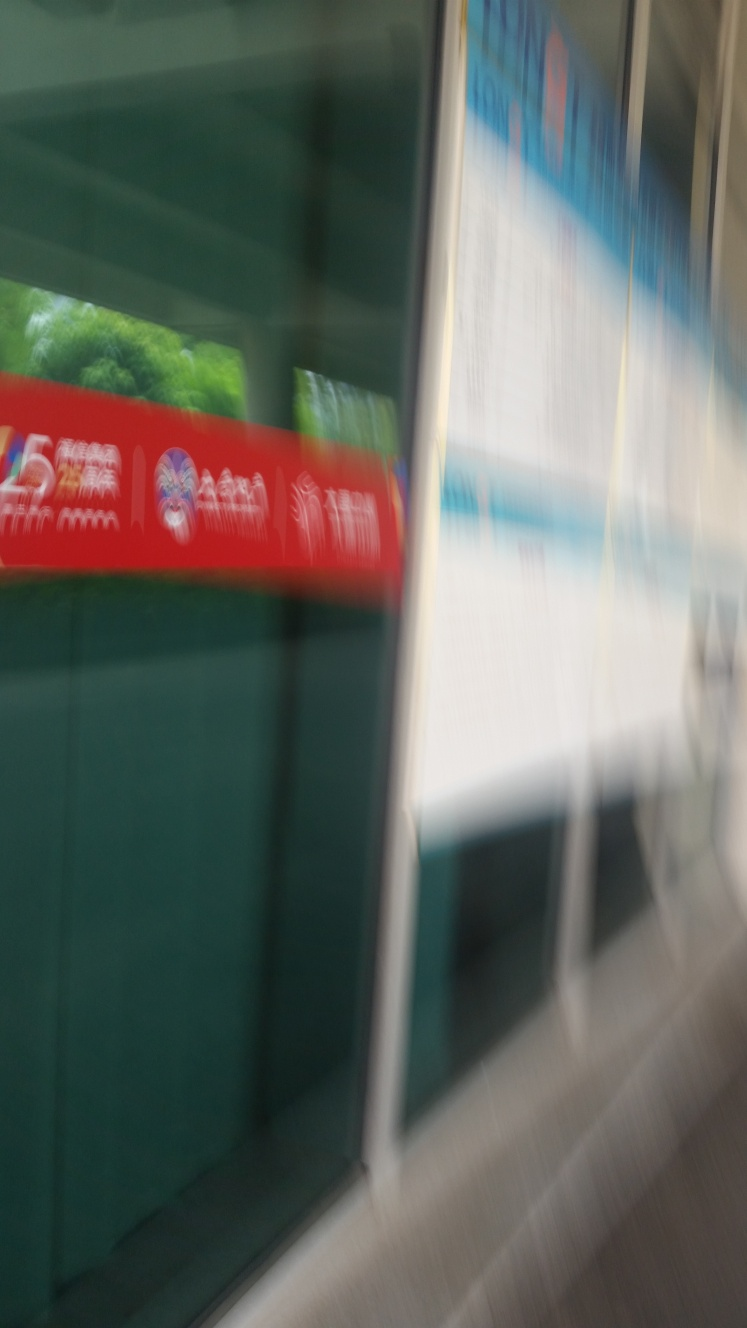What is the overall quality of this image? The quality of the provided image is below average due to the significant motion blur, which obscures the details of the scene. It seems to capture a rapid movement, likely from a vehicle, which results in the lack of sharpness and clarity that are usually desired for a high-quality image. 